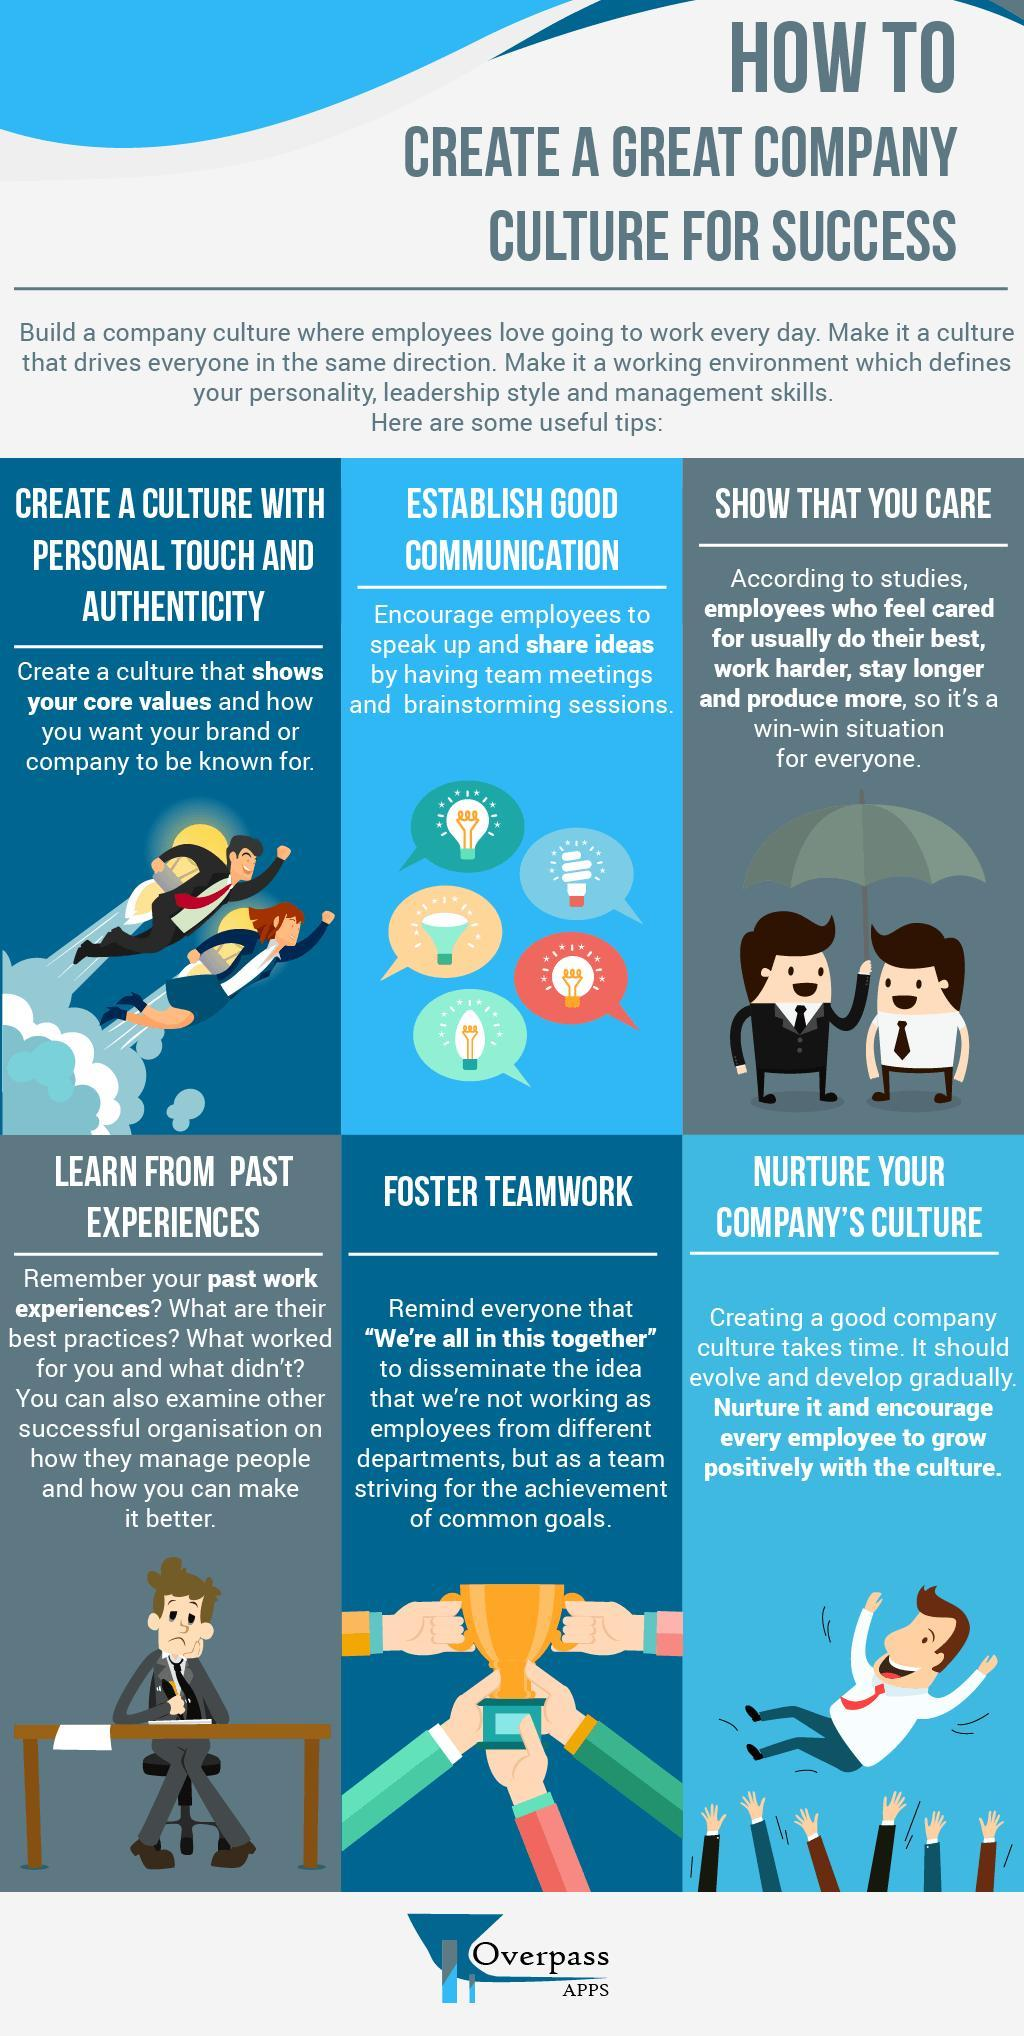What is the fifth step to create a great company culture for success?
Answer the question with a short phrase. Foster Teamwork What is the sixth step to create a great company culture for success? Nurture your company's culture Which is the third step to create a great company culture for success? Show that you care 